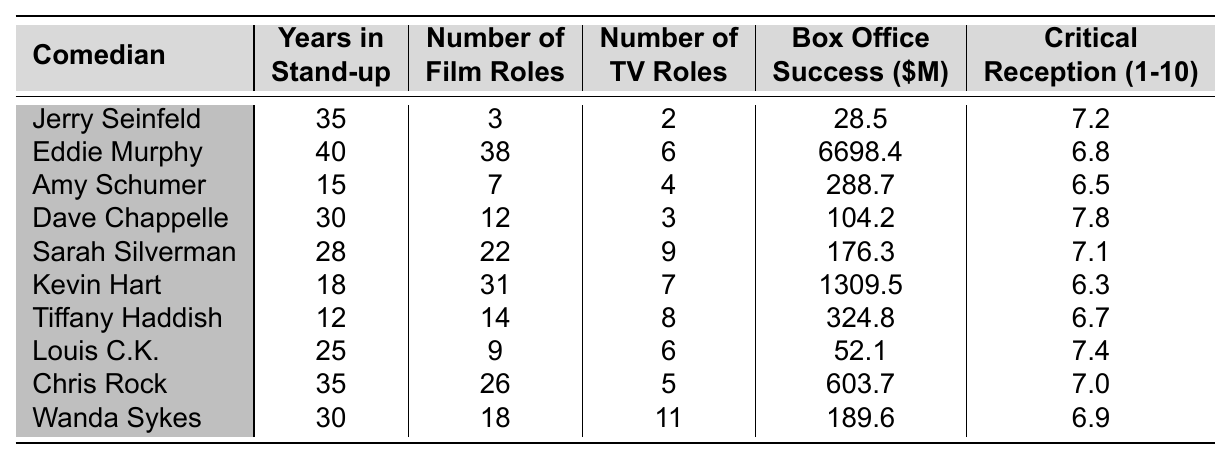What is the critical reception score of Kevin Hart? According to the table, Kevin Hart has a critical reception score of 6.3.
Answer: 6.3 Who has the highest number of film roles? By looking at the number of film roles, Eddie Murphy has the highest at 38.
Answer: Eddie Murphy How many TV roles does Sarah Silverman have? Sarah Silverman has 9 TV roles as indicated in the table.
Answer: 9 What is the average box office success of comedians listed in the table? The total box office success amounts to 7,610.1 million dollars, and there are 10 comedians, so the average box office success is 7,610.1 / 10 = 761.01 million dollars.
Answer: 761.01 million dollars Is it true that Dave Chappelle has more film roles than Tiffany Haddish? Dave Chappelle has 12 film roles while Tiffany Haddish has 14, making the statement false.
Answer: No Which comedian has the longest stand-up career in years? Both Jerry Seinfeld and Chris Rock have 35 years in stand-up, which is the longest listed.
Answer: Jerry Seinfeld and Chris Rock What is the difference between the highest and lowest critical reception scores? The highest critical reception is 7.8 (Dave Chappelle) and the lowest is 6.3 (Kevin Hart), so the difference is 7.8 - 6.3 = 1.5.
Answer: 1.5 Who has more film roles, Chris Rock or Kevin Hart? Chris Rock has 26 film roles and Kevin Hart has 31 film roles, so Kevin Hart has more.
Answer: Kevin Hart What is the total number of roles (film and TV) for Amy Schumer? Amy Schumer has a total of 7 film roles and 4 TV roles, so the total is 7 + 4 = 11.
Answer: 11 Which comedian achieved the least box office success? The least box office success is recorded for Jerry Seinfeld with 28.5 million dollars.
Answer: Jerry Seinfeld How many comedians have a critical reception score of 7 or higher? Analyzing the scores, there are 5 comedians with a score of 7 or higher: Jerry Seinfeld, Dave Chappelle, Sarah Silverman, Chris Rock, and Wanda Sykes.
Answer: 5 